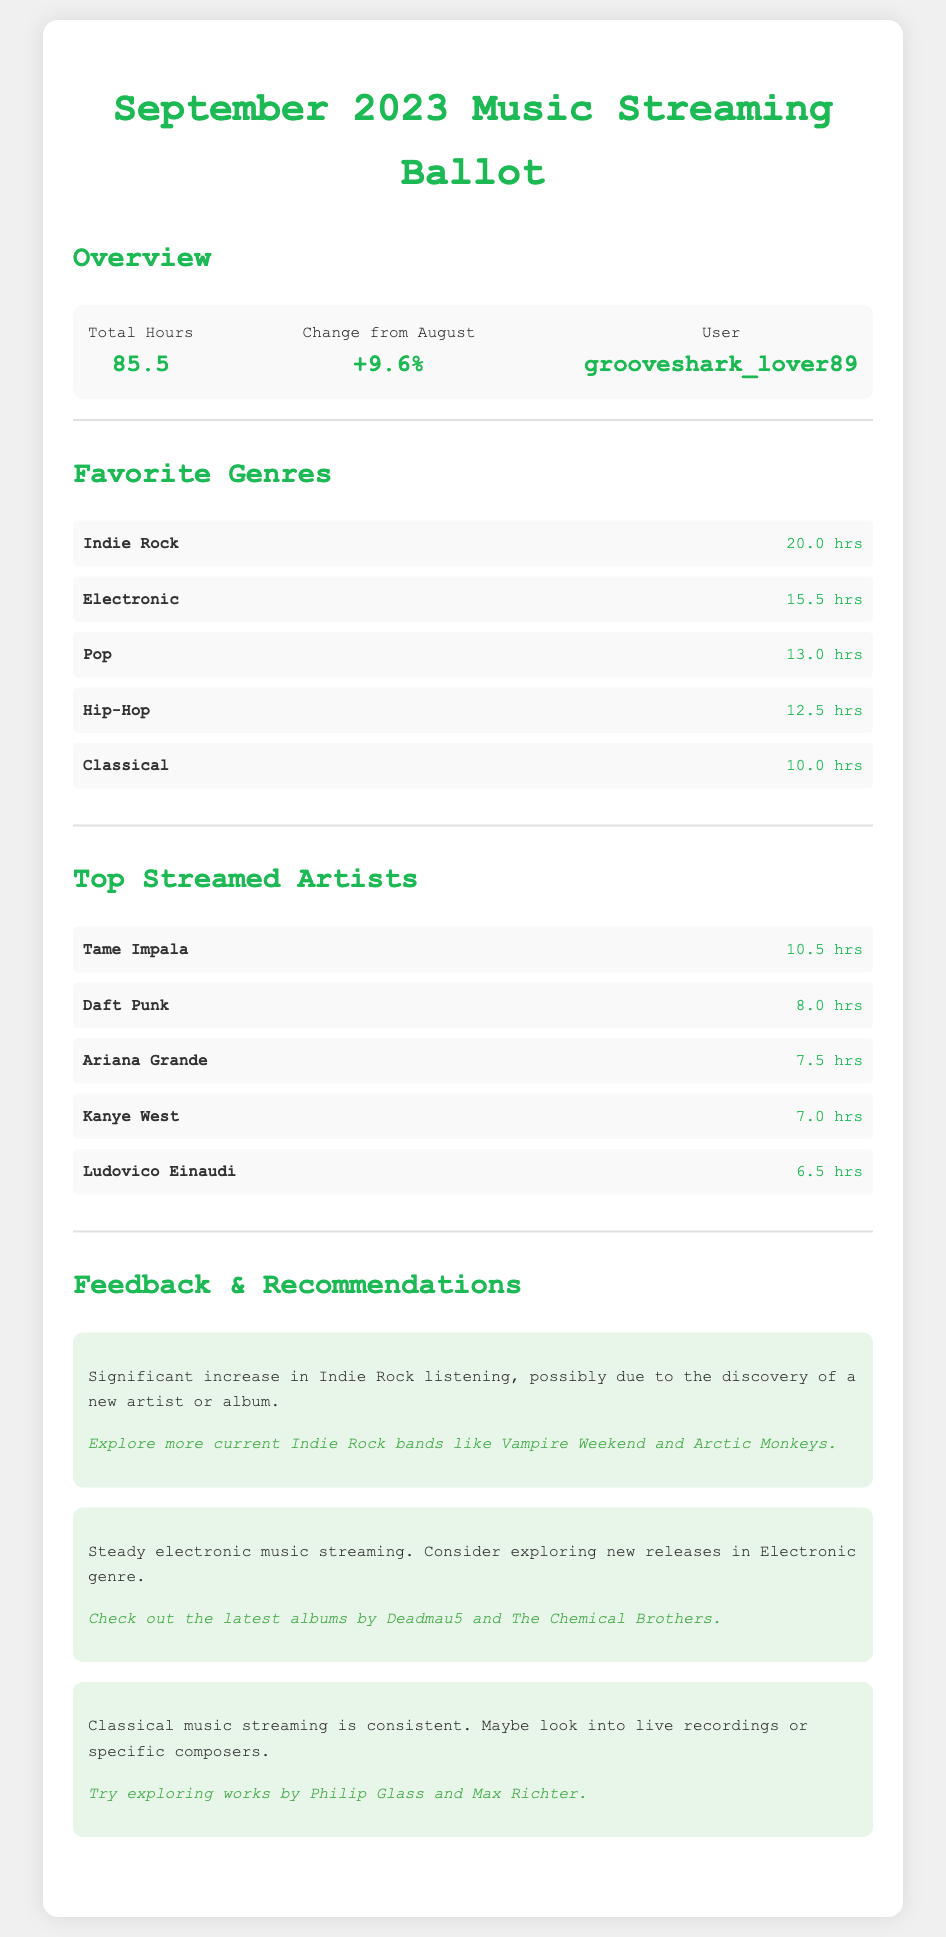What is the total hours spent listening to music? The total hours are provided in the document, which is 85.5 hours for September 2023.
Answer: 85.5 What genre had the highest listening hours? The genre with the highest listening hours listed in the document is Indie Rock at 20.0 hours.
Answer: Indie Rock How much did the total hours change from August? The change from August is indicated as a percentage increase of 9.6%.
Answer: +9.6% Who is the top-streamed artist in September? The top-streamed artist's name in the document is Tame Impala with 10.5 hours.
Answer: Tame Impala How many hours were spent on Classical music? The document lists Classical music as having 10.0 hours of listening.
Answer: 10.0 hrs What is the recommended artist to explore for Indie Rock? The document suggests exploring Vampire Weekend and Arctic Monkeys for Indie Rock recommendations.
Answer: Vampire Weekend and Arctic Monkeys How many hours were dedicated to Electronic music? The document specifies that Electronic music was streamed for 15.5 hours.
Answer: 15.5 hrs Was there a significant increase in any genre? The feedback in the document states there was a significant increase in Indie Rock listening.
Answer: Yes What is the user's unique identifier in the document? The unique identifier for the user mentioned is grooveshark_lover89.
Answer: grooveshark_lover89 